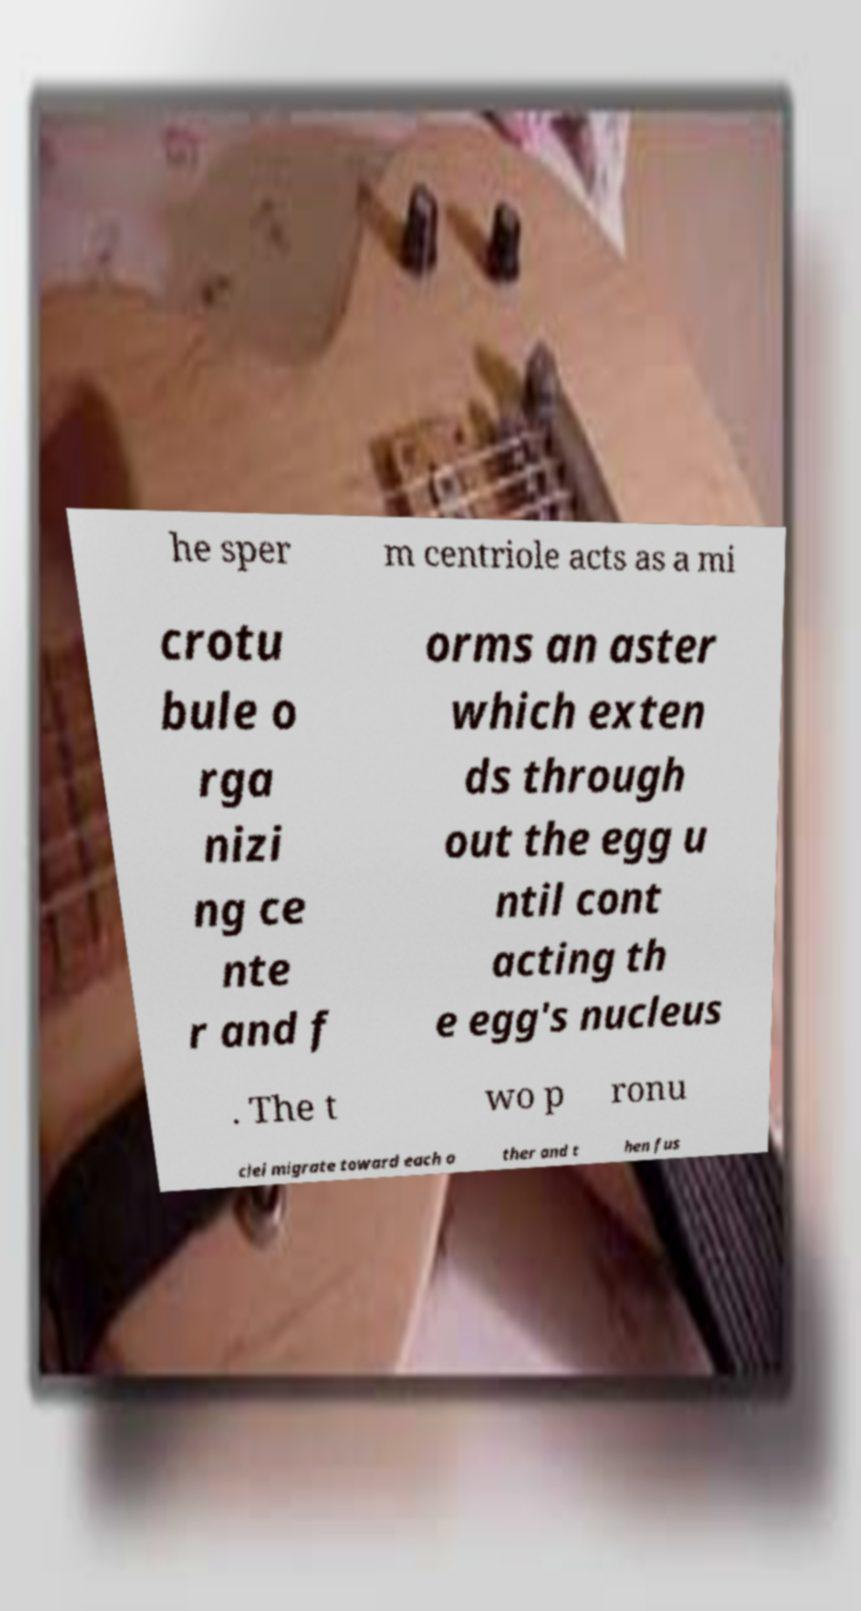Please identify and transcribe the text found in this image. he sper m centriole acts as a mi crotu bule o rga nizi ng ce nte r and f orms an aster which exten ds through out the egg u ntil cont acting th e egg's nucleus . The t wo p ronu clei migrate toward each o ther and t hen fus 